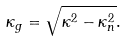Convert formula to latex. <formula><loc_0><loc_0><loc_500><loc_500>\kappa _ { g } & = \sqrt { \kappa ^ { 2 } - \kappa _ { n } ^ { 2 } } .</formula> 